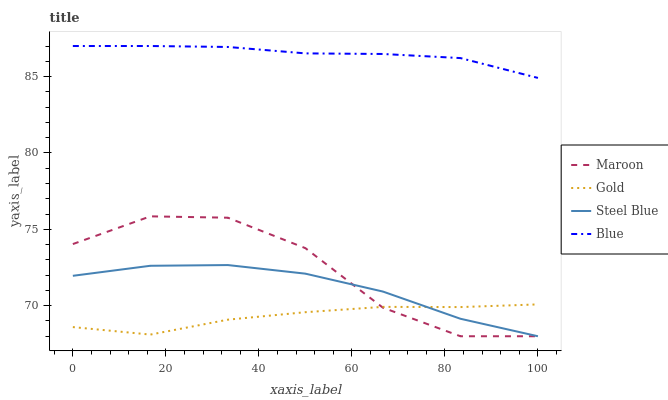Does Maroon have the minimum area under the curve?
Answer yes or no. No. Does Maroon have the maximum area under the curve?
Answer yes or no. No. Is Gold the smoothest?
Answer yes or no. No. Is Gold the roughest?
Answer yes or no. No. Does Gold have the lowest value?
Answer yes or no. No. Does Maroon have the highest value?
Answer yes or no. No. Is Steel Blue less than Blue?
Answer yes or no. Yes. Is Blue greater than Maroon?
Answer yes or no. Yes. Does Steel Blue intersect Blue?
Answer yes or no. No. 